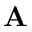<formula> <loc_0><loc_0><loc_500><loc_500>A</formula> 